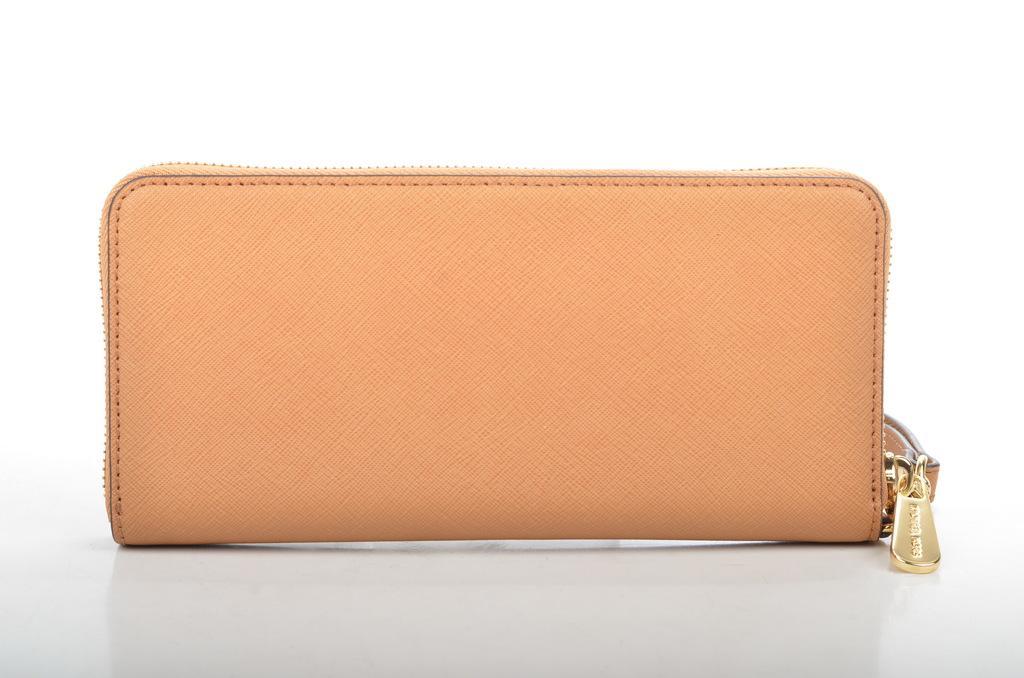How would you summarize this image in a sentence or two? In this picture we can see an orange color purse placed on a white platform. 